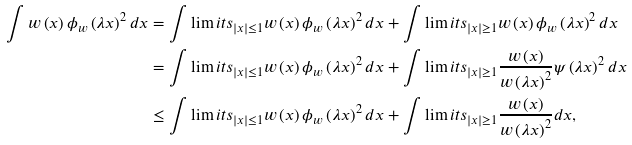Convert formula to latex. <formula><loc_0><loc_0><loc_500><loc_500>\int w \left ( x \right ) \phi _ { w } \left ( \lambda x \right ) ^ { 2 } d x & = \int \lim i t s _ { \left | x \right | \leq 1 } w \left ( x \right ) \phi _ { w } \left ( \lambda x \right ) ^ { 2 } d x + \int \lim i t s _ { \left | x \right | \geq 1 } w \left ( x \right ) \phi _ { w } \left ( \lambda x \right ) ^ { 2 } d x \\ & = \int \lim i t s _ { \left | x \right | \leq 1 } w \left ( x \right ) \phi _ { w } \left ( \lambda x \right ) ^ { 2 } d x + \int \lim i t s _ { \left | x \right | \geq 1 } \frac { w \left ( x \right ) } { w \left ( \lambda x \right ) ^ { 2 } } \psi \left ( \lambda x \right ) ^ { 2 } d x \\ & \leq \int \lim i t s _ { \left | x \right | \leq 1 } w \left ( x \right ) \phi _ { w } \left ( \lambda x \right ) ^ { 2 } d x + \int \lim i t s _ { \left | x \right | \geq 1 } \frac { w \left ( x \right ) } { w \left ( \lambda x \right ) ^ { 2 } } d x ,</formula> 